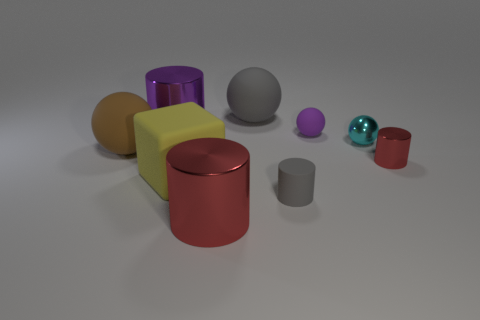If we were to arrange the objects by weight, what would be the order, assuming they're all made of the same material? If we assume all objects are made of the same material, their weight would be directly related to their volume. The yellow cube, being the largest object, would likely weigh the most, followed by the orange cylinder, purple cylinder, gray sphere, red cylinder, smaller purple sphere, and finally the small teal sphere, which would weigh the least. 